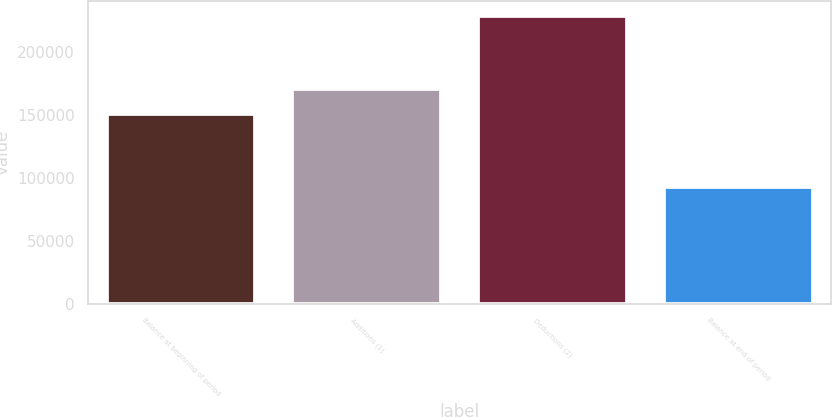Convert chart to OTSL. <chart><loc_0><loc_0><loc_500><loc_500><bar_chart><fcel>Balance at beginning of period<fcel>Additions (1)<fcel>Deductions (2)<fcel>Balance at end of period<nl><fcel>150631<fcel>170715<fcel>228691<fcel>92655<nl></chart> 